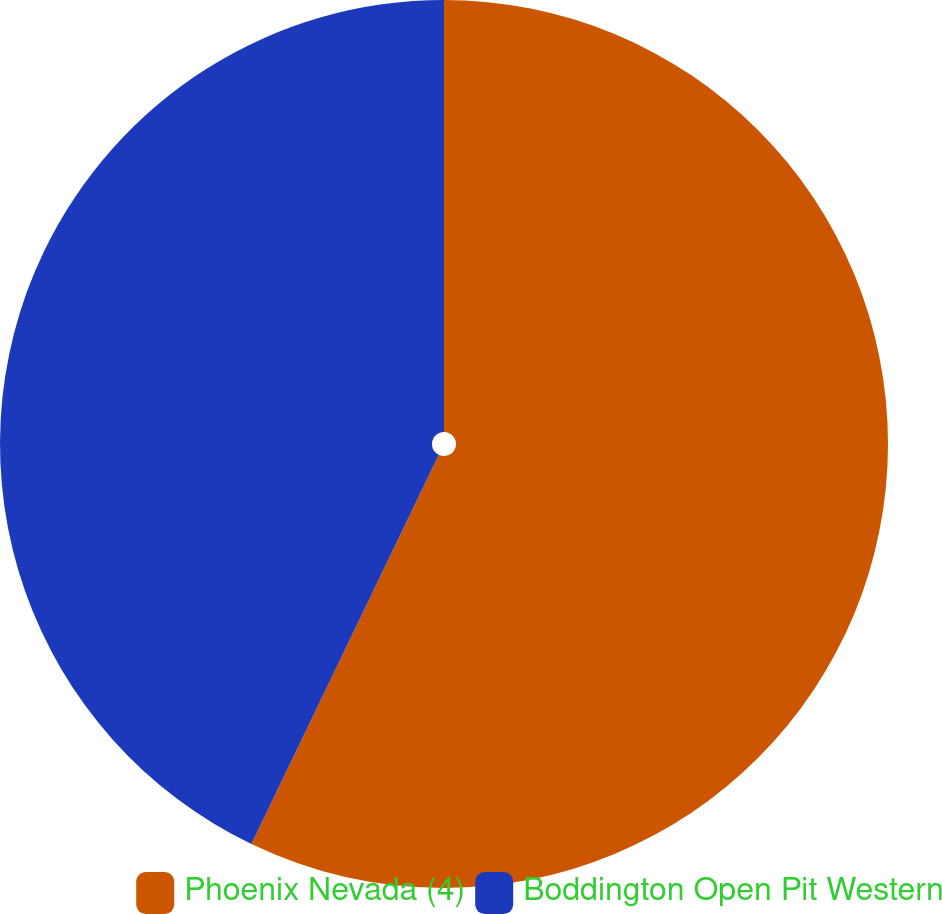<chart> <loc_0><loc_0><loc_500><loc_500><pie_chart><fcel>Phoenix Nevada (4)<fcel>Boddington Open Pit Western<nl><fcel>57.14%<fcel>42.86%<nl></chart> 